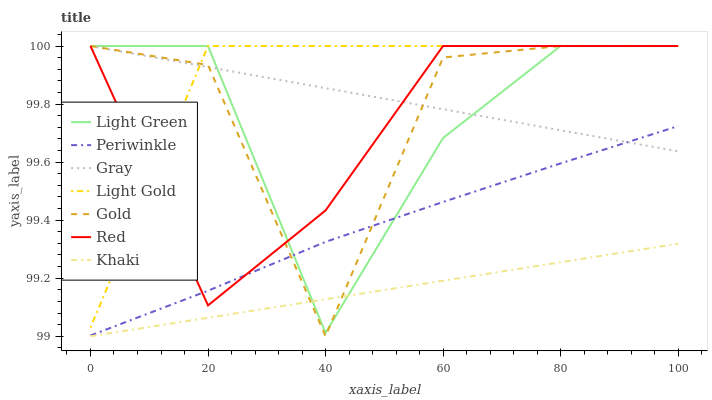Does Khaki have the minimum area under the curve?
Answer yes or no. Yes. Does Light Gold have the maximum area under the curve?
Answer yes or no. Yes. Does Gold have the minimum area under the curve?
Answer yes or no. No. Does Gold have the maximum area under the curve?
Answer yes or no. No. Is Gray the smoothest?
Answer yes or no. Yes. Is Gold the roughest?
Answer yes or no. Yes. Is Khaki the smoothest?
Answer yes or no. No. Is Khaki the roughest?
Answer yes or no. No. Does Khaki have the lowest value?
Answer yes or no. Yes. Does Gold have the lowest value?
Answer yes or no. No. Does Red have the highest value?
Answer yes or no. Yes. Does Khaki have the highest value?
Answer yes or no. No. Is Khaki less than Periwinkle?
Answer yes or no. Yes. Is Light Gold greater than Khaki?
Answer yes or no. Yes. Does Red intersect Gray?
Answer yes or no. Yes. Is Red less than Gray?
Answer yes or no. No. Is Red greater than Gray?
Answer yes or no. No. Does Khaki intersect Periwinkle?
Answer yes or no. No. 